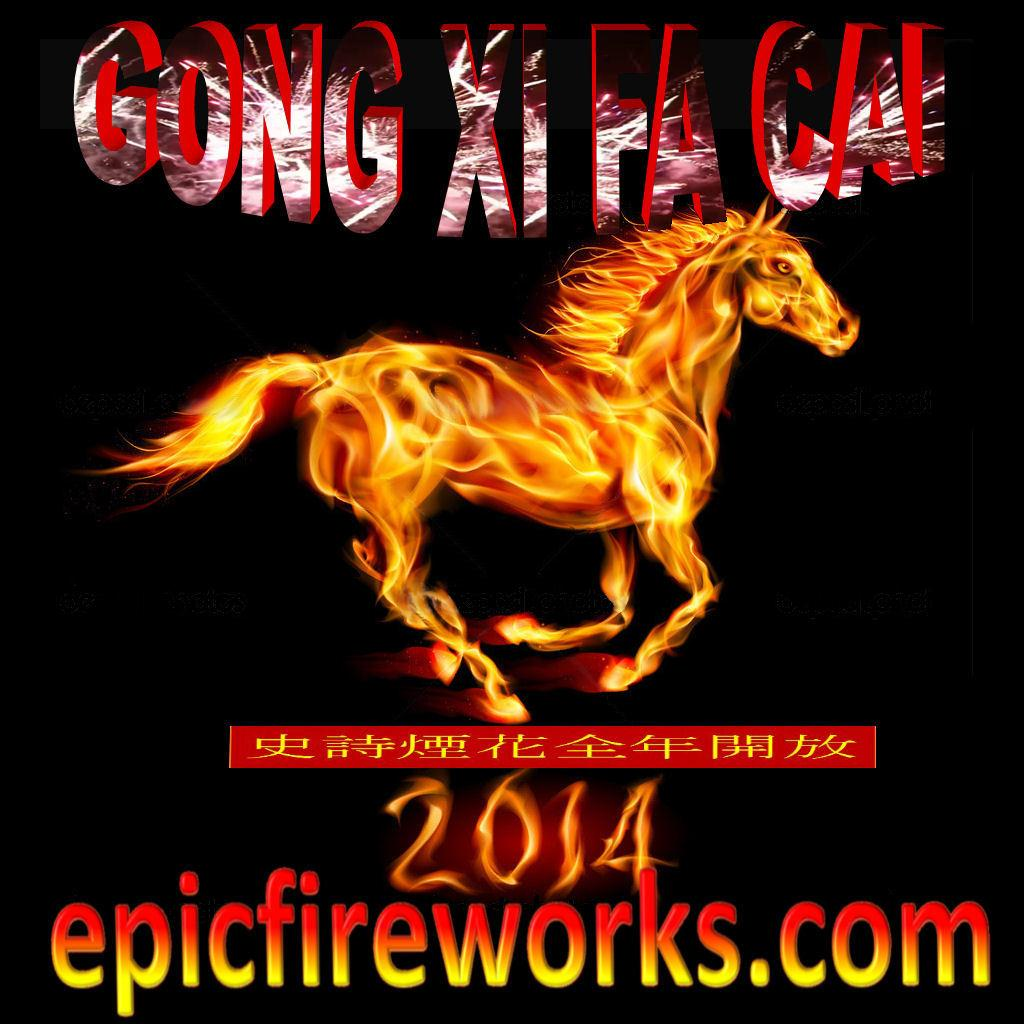What is present in the image that contains information or a message? There is a poster in the image. What can be found on the poster besides the image? There is writing on the poster. What type of animal is depicted on the poster? There is an image of a horse on the poster. What type of knife is being used to mine the coal in the image? There is no knife or coal present in the image; it features a poster with writing and an image of a horse. 